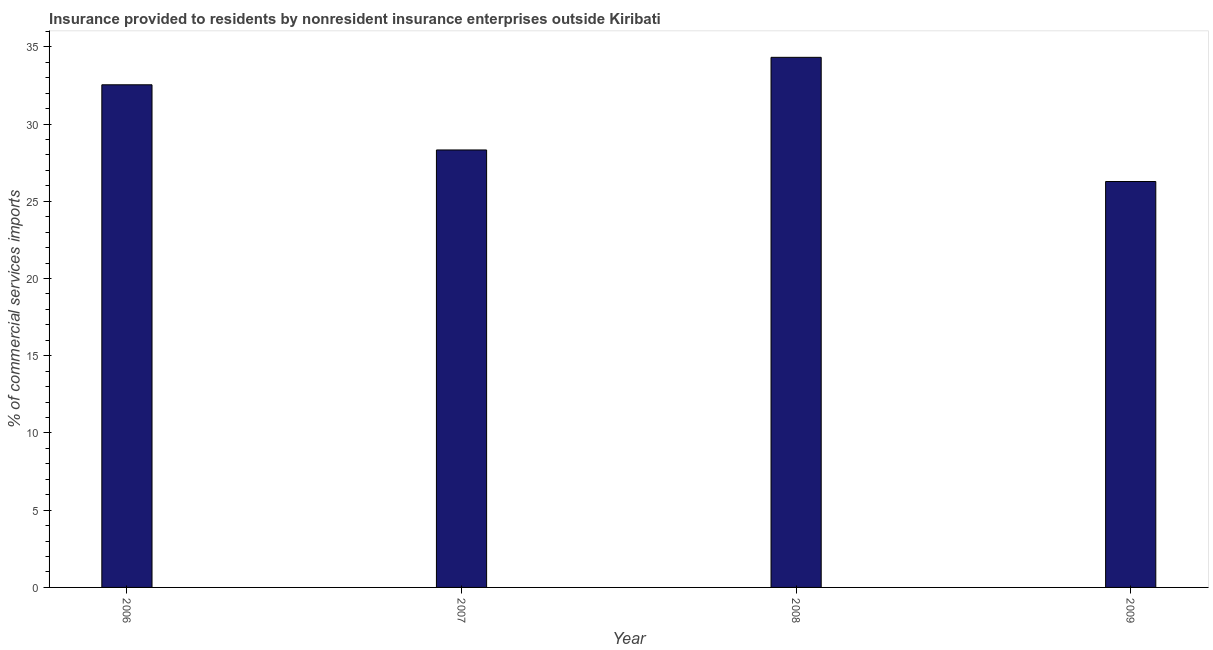What is the title of the graph?
Keep it short and to the point. Insurance provided to residents by nonresident insurance enterprises outside Kiribati. What is the label or title of the Y-axis?
Your answer should be compact. % of commercial services imports. What is the insurance provided by non-residents in 2009?
Give a very brief answer. 26.28. Across all years, what is the maximum insurance provided by non-residents?
Keep it short and to the point. 34.32. Across all years, what is the minimum insurance provided by non-residents?
Your answer should be compact. 26.28. In which year was the insurance provided by non-residents maximum?
Keep it short and to the point. 2008. What is the sum of the insurance provided by non-residents?
Your answer should be very brief. 121.48. What is the difference between the insurance provided by non-residents in 2006 and 2009?
Offer a very short reply. 6.26. What is the average insurance provided by non-residents per year?
Your response must be concise. 30.37. What is the median insurance provided by non-residents?
Ensure brevity in your answer.  30.44. In how many years, is the insurance provided by non-residents greater than 19 %?
Provide a succinct answer. 4. What is the ratio of the insurance provided by non-residents in 2006 to that in 2009?
Provide a short and direct response. 1.24. Is the insurance provided by non-residents in 2006 less than that in 2009?
Offer a very short reply. No. Is the difference between the insurance provided by non-residents in 2006 and 2009 greater than the difference between any two years?
Your response must be concise. No. What is the difference between the highest and the second highest insurance provided by non-residents?
Keep it short and to the point. 1.78. What is the difference between the highest and the lowest insurance provided by non-residents?
Your response must be concise. 8.04. In how many years, is the insurance provided by non-residents greater than the average insurance provided by non-residents taken over all years?
Offer a very short reply. 2. What is the difference between two consecutive major ticks on the Y-axis?
Offer a very short reply. 5. What is the % of commercial services imports of 2006?
Make the answer very short. 32.55. What is the % of commercial services imports of 2007?
Your response must be concise. 28.33. What is the % of commercial services imports in 2008?
Your answer should be very brief. 34.32. What is the % of commercial services imports in 2009?
Make the answer very short. 26.28. What is the difference between the % of commercial services imports in 2006 and 2007?
Your answer should be very brief. 4.22. What is the difference between the % of commercial services imports in 2006 and 2008?
Provide a succinct answer. -1.78. What is the difference between the % of commercial services imports in 2006 and 2009?
Your response must be concise. 6.26. What is the difference between the % of commercial services imports in 2007 and 2008?
Provide a succinct answer. -6. What is the difference between the % of commercial services imports in 2007 and 2009?
Your response must be concise. 2.04. What is the difference between the % of commercial services imports in 2008 and 2009?
Offer a terse response. 8.04. What is the ratio of the % of commercial services imports in 2006 to that in 2007?
Keep it short and to the point. 1.15. What is the ratio of the % of commercial services imports in 2006 to that in 2008?
Give a very brief answer. 0.95. What is the ratio of the % of commercial services imports in 2006 to that in 2009?
Offer a very short reply. 1.24. What is the ratio of the % of commercial services imports in 2007 to that in 2008?
Provide a succinct answer. 0.82. What is the ratio of the % of commercial services imports in 2007 to that in 2009?
Ensure brevity in your answer.  1.08. What is the ratio of the % of commercial services imports in 2008 to that in 2009?
Your answer should be compact. 1.31. 